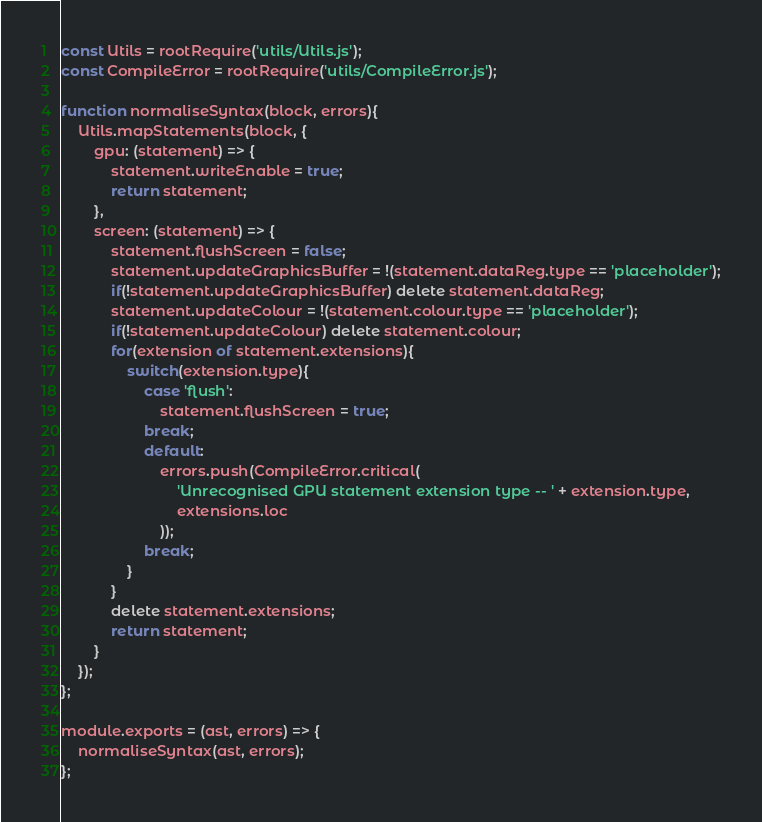Convert code to text. <code><loc_0><loc_0><loc_500><loc_500><_JavaScript_>const Utils = rootRequire('utils/Utils.js');
const CompileError = rootRequire('utils/CompileError.js');

function normaliseSyntax(block, errors){
	Utils.mapStatements(block, {
		gpu: (statement) => {
			statement.writeEnable = true;
			return statement;
		},
		screen: (statement) => {
			statement.flushScreen = false;
			statement.updateGraphicsBuffer = !(statement.dataReg.type == 'placeholder');
			if(!statement.updateGraphicsBuffer) delete statement.dataReg;
			statement.updateColour = !(statement.colour.type == 'placeholder');
			if(!statement.updateColour) delete statement.colour;
			for(extension of statement.extensions){
				switch(extension.type){
					case 'flush':
						statement.flushScreen = true;
					break;
					default:
						errors.push(CompileError.critical(
							'Unrecognised GPU statement extension type -- ' + extension.type,
							extensions.loc
						));
					break;
				}
			}
			delete statement.extensions;
			return statement;
		}
	});
};

module.exports = (ast, errors) => {
	normaliseSyntax(ast, errors);
};
</code> 